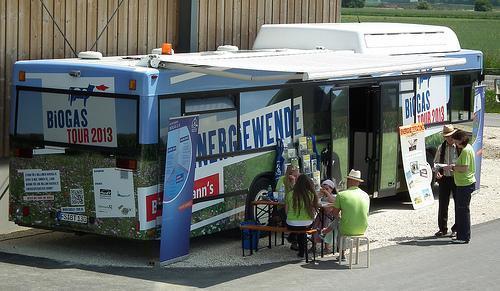How many vehicles are in the picture?
Give a very brief answer. 1. 